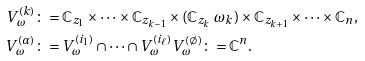Convert formula to latex. <formula><loc_0><loc_0><loc_500><loc_500>V _ { \omega } ^ { ( k ) } & \colon = \mathbb { C } _ { z _ { 1 } } \times \dots \times \mathbb { C } _ { z _ { k - 1 } } \times ( \mathbb { C } _ { z _ { k } } \ \omega _ { k } ) \times \mathbb { C } _ { z _ { k + 1 } } \times \dots \times \mathbb { C } _ { n } , \\ V _ { \omega } ^ { ( \alpha ) } & \colon = V _ { \omega } ^ { ( i _ { 1 } ) } \cap \dots \cap V _ { \omega } ^ { ( i _ { \ell } ) } V _ { \omega } ^ { ( \emptyset ) } \colon = \mathbb { C } ^ { n } .</formula> 